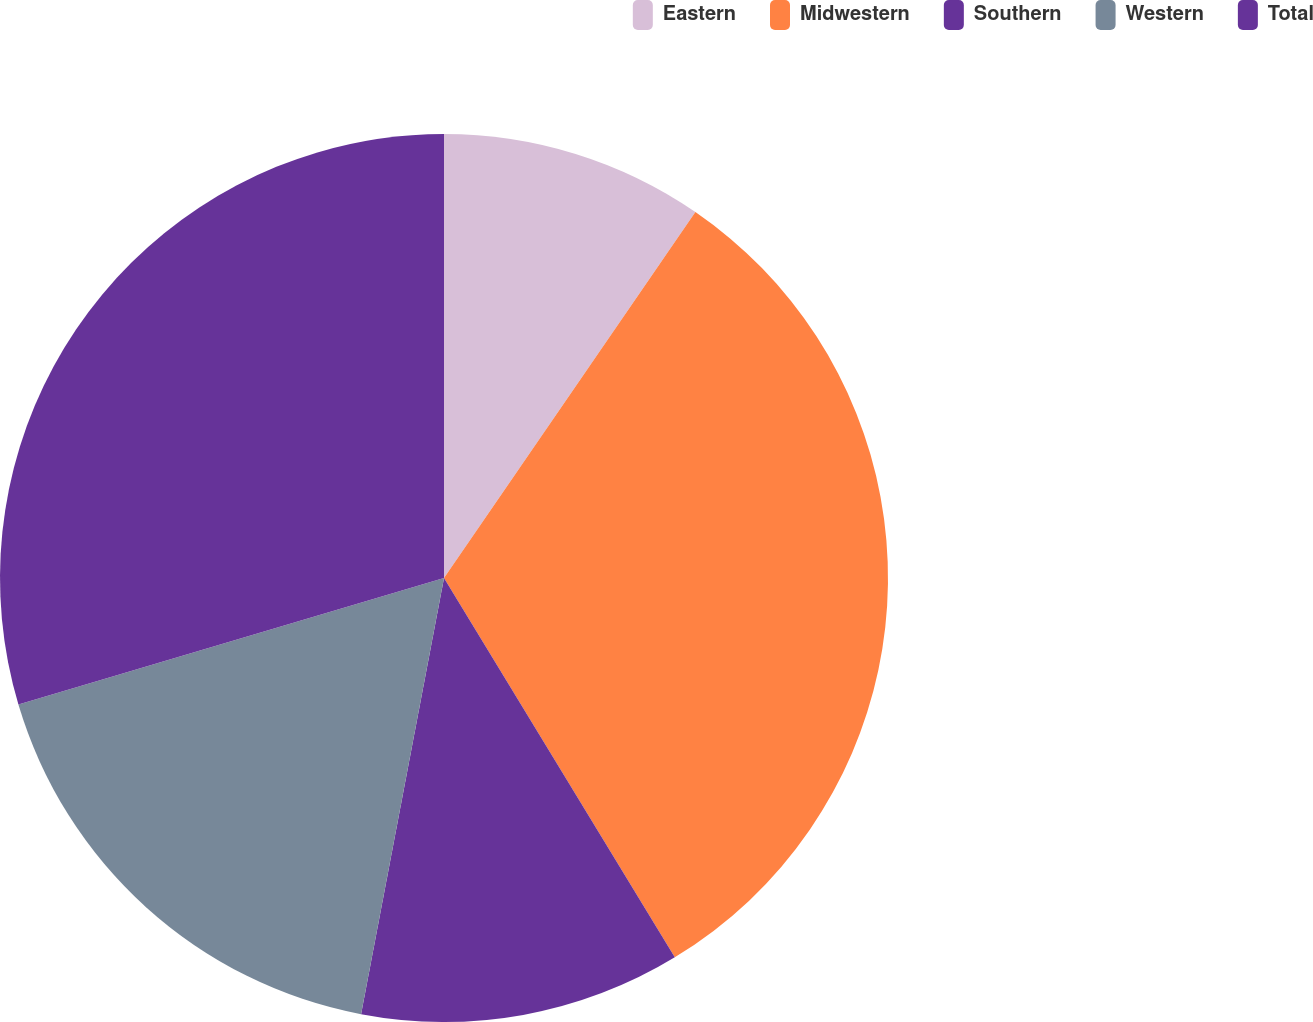Convert chart. <chart><loc_0><loc_0><loc_500><loc_500><pie_chart><fcel>Eastern<fcel>Midwestern<fcel>Southern<fcel>Western<fcel>Total<nl><fcel>9.58%<fcel>31.72%<fcel>11.69%<fcel>17.41%<fcel>29.6%<nl></chart> 